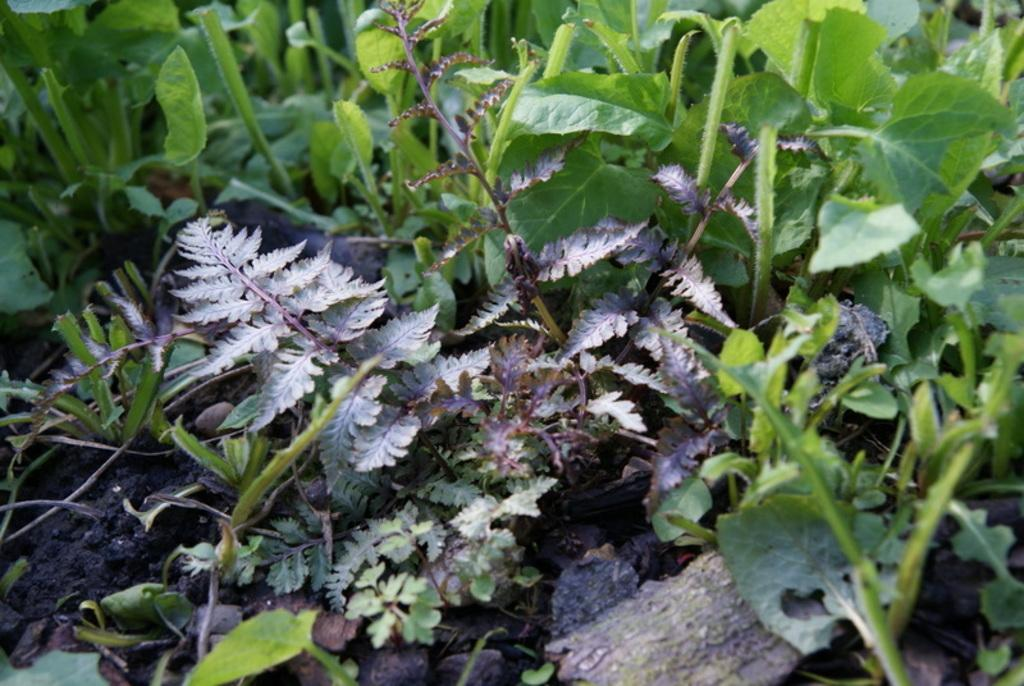What type of plants are present in the image? There are plants with green leaves in the image. What can be seen at the bottom of the image? There is sand visible at the bottom of the image. What book is the person reading in the image? There is no person or book present in the image; it only features plants and sand. How many nails are visible in the image? There are no nails visible in the image. 